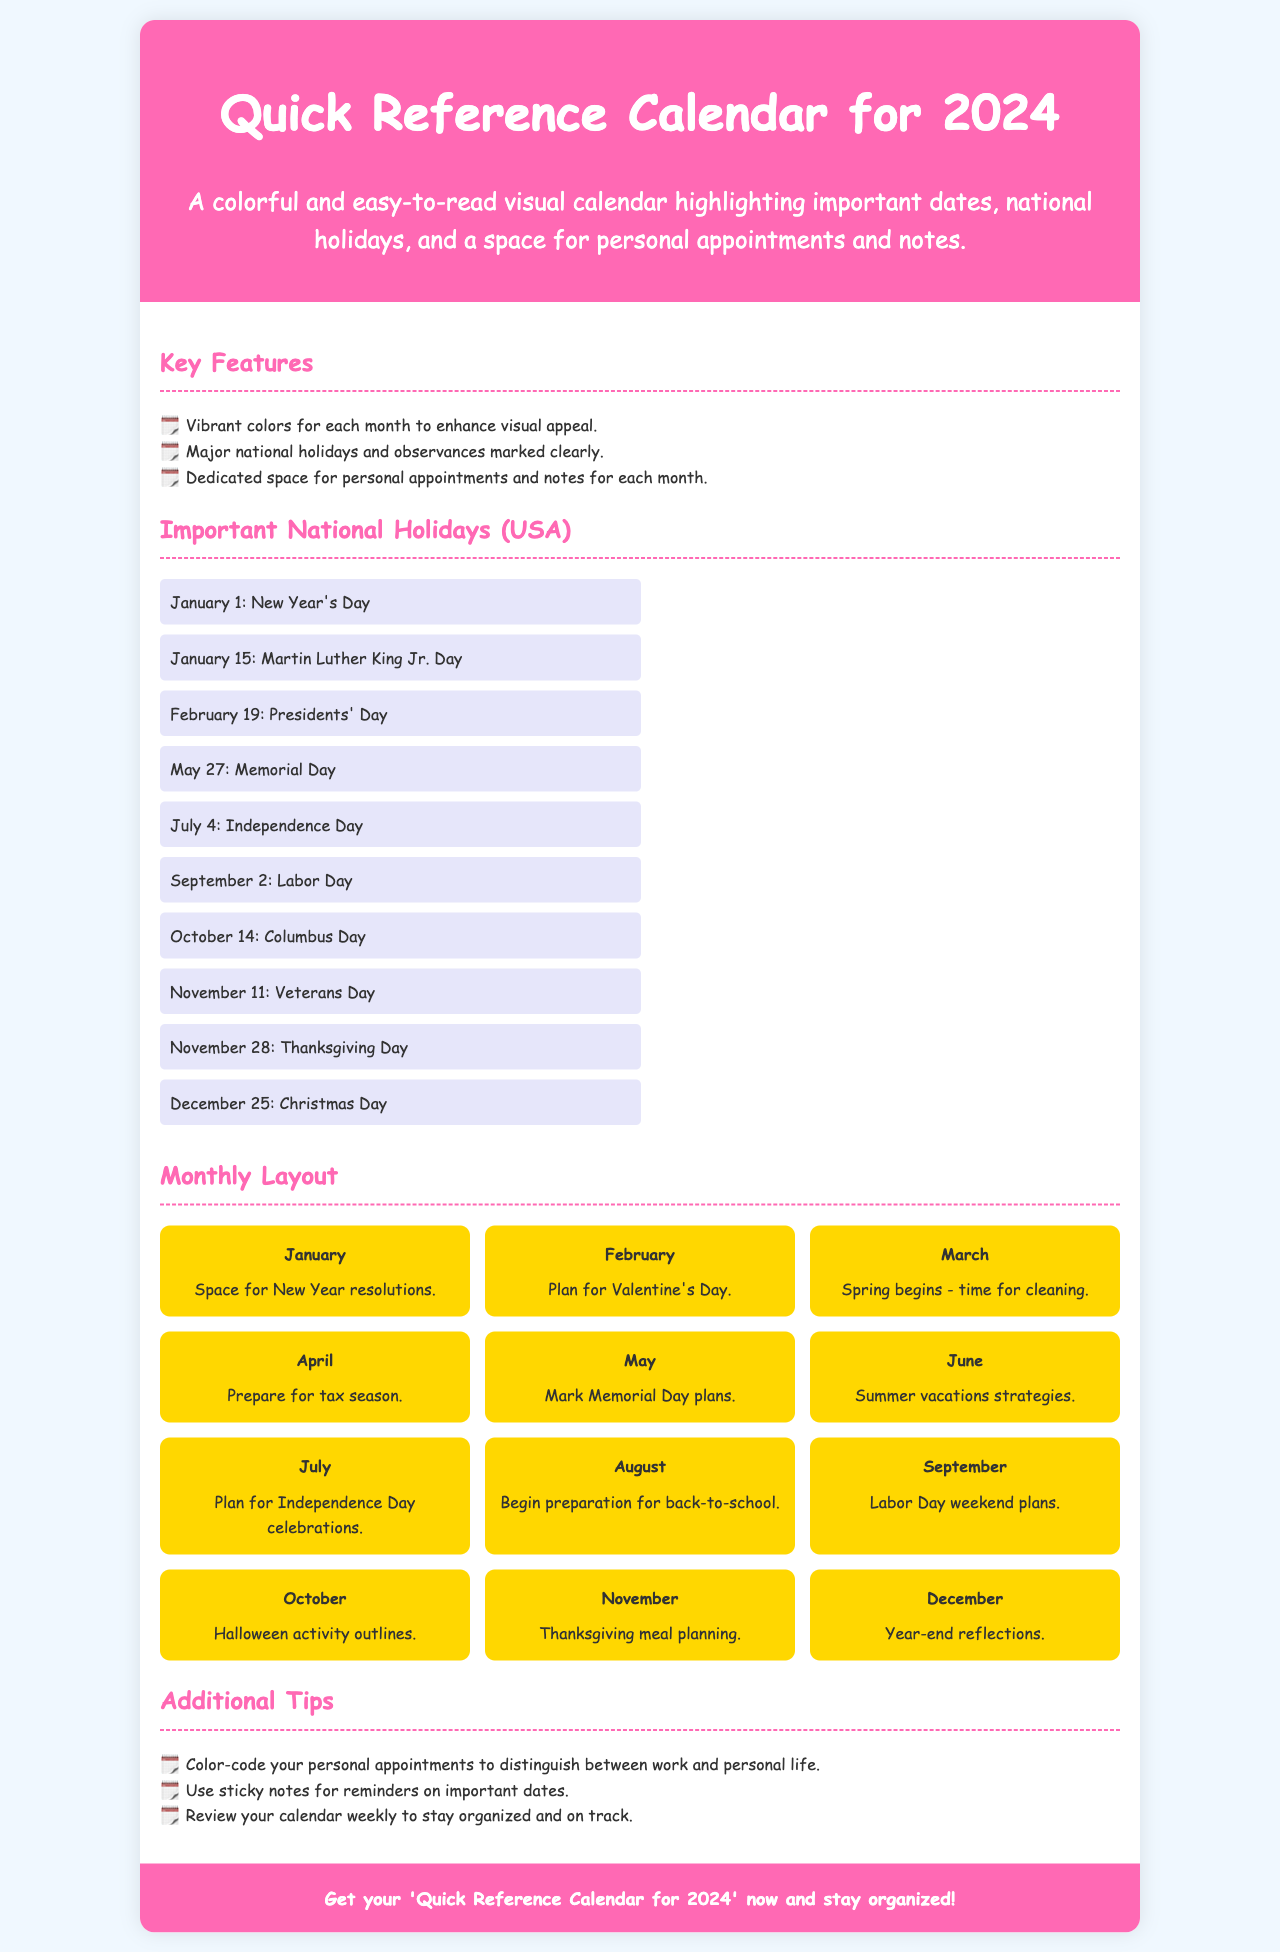what is the title of the document? The title of the document is presented in the header section.
Answer: Quick Reference Calendar for 2024 how many important national holidays are listed? The number of holidays is mentioned in the section titled "Important National Holidays (USA)".
Answer: 10 which day is celebrated as Independence Day? Independence Day is specifically mentioned in the holiday list.
Answer: July 4 what is one tip for using the calendar effectively? The tips are provided in the "Additional Tips" section.
Answer: Color-code your personal appointments what color is used for the header background? The header background color is specified in the CSS styles within the document.
Answer: #ff69b4 which month includes Valentine's Day? The month associated with Valentine's Day is shown in the "Monthly Layout" section.
Answer: February what is highlighted as a feature of the calendar? Features are listed in the "Key Features" section of the document.
Answer: Dedicated space for personal appointments and notes what is the last month mentioned in the monthly layout? The last month can be found at the end of the "Monthly Layout" section.
Answer: December 